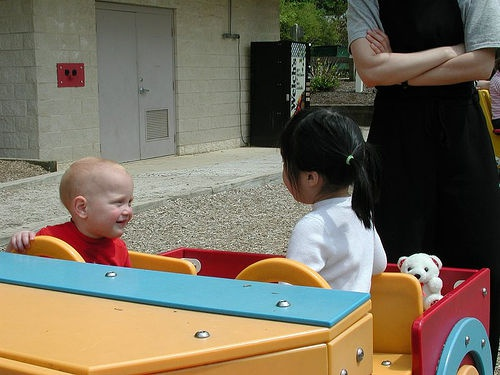Describe the objects in this image and their specific colors. I can see people in black, gray, darkgray, and maroon tones, people in black, lightgray, and darkgray tones, people in black, gray, maroon, darkgray, and brown tones, teddy bear in black, lightgray, darkgray, and gray tones, and people in black and gray tones in this image. 